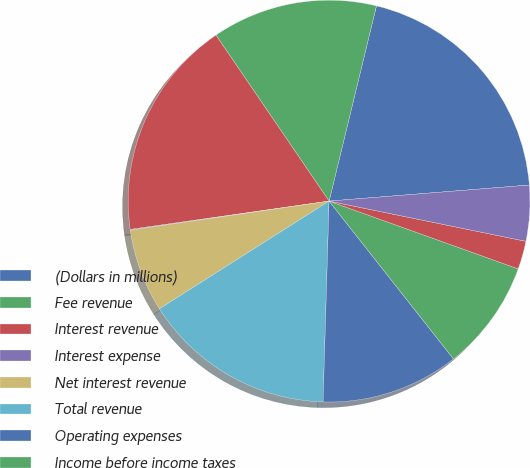Convert chart. <chart><loc_0><loc_0><loc_500><loc_500><pie_chart><fcel>(Dollars in millions)<fcel>Fee revenue<fcel>Interest revenue<fcel>Interest expense<fcel>Net interest revenue<fcel>Total revenue<fcel>Operating expenses<fcel>Income before income taxes<fcel>Income taxes<fcel>Net Income<nl><fcel>19.94%<fcel>13.31%<fcel>17.73%<fcel>0.06%<fcel>6.69%<fcel>15.52%<fcel>11.1%<fcel>8.9%<fcel>2.27%<fcel>4.48%<nl></chart> 